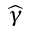<formula> <loc_0><loc_0><loc_500><loc_500>\widehat { \gamma }</formula> 